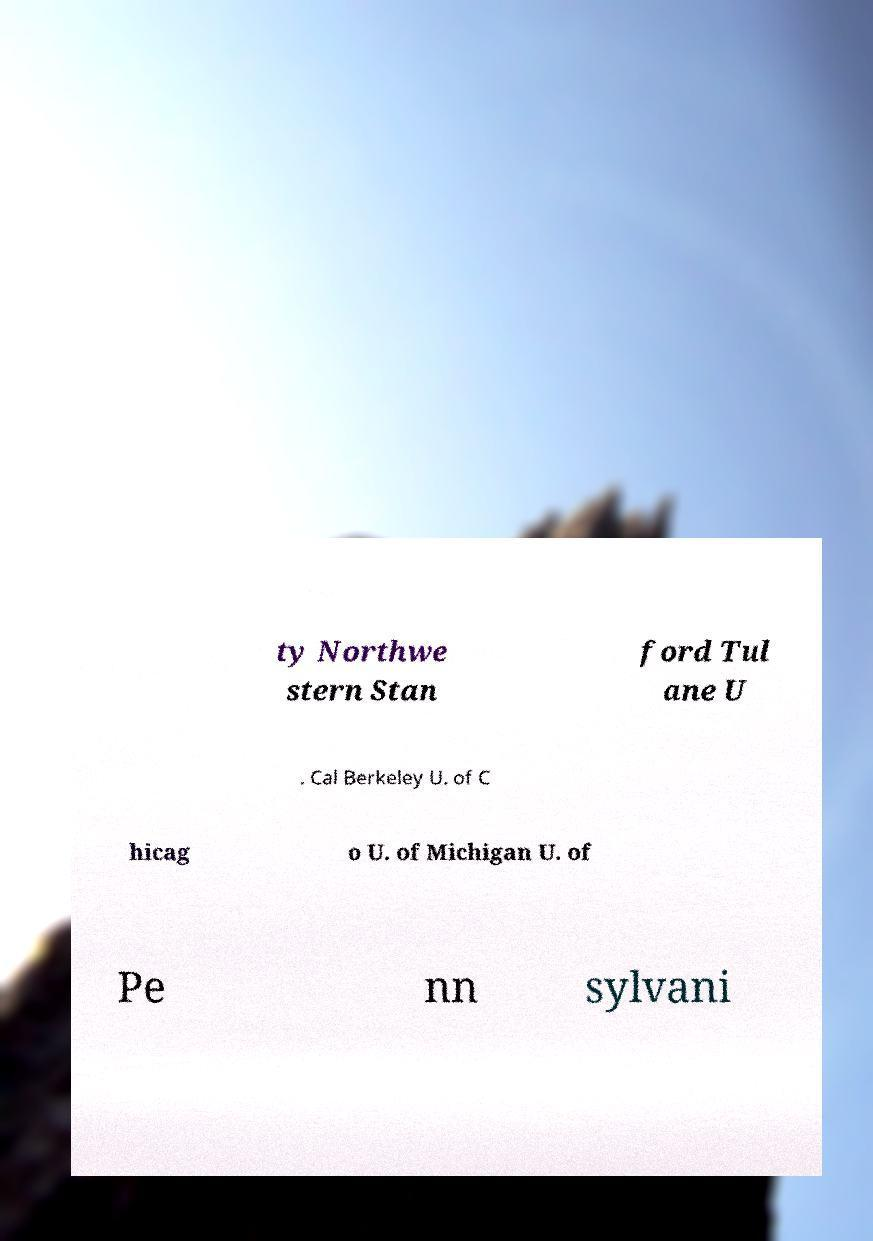Could you assist in decoding the text presented in this image and type it out clearly? ty Northwe stern Stan ford Tul ane U . Cal Berkeley U. of C hicag o U. of Michigan U. of Pe nn sylvani 